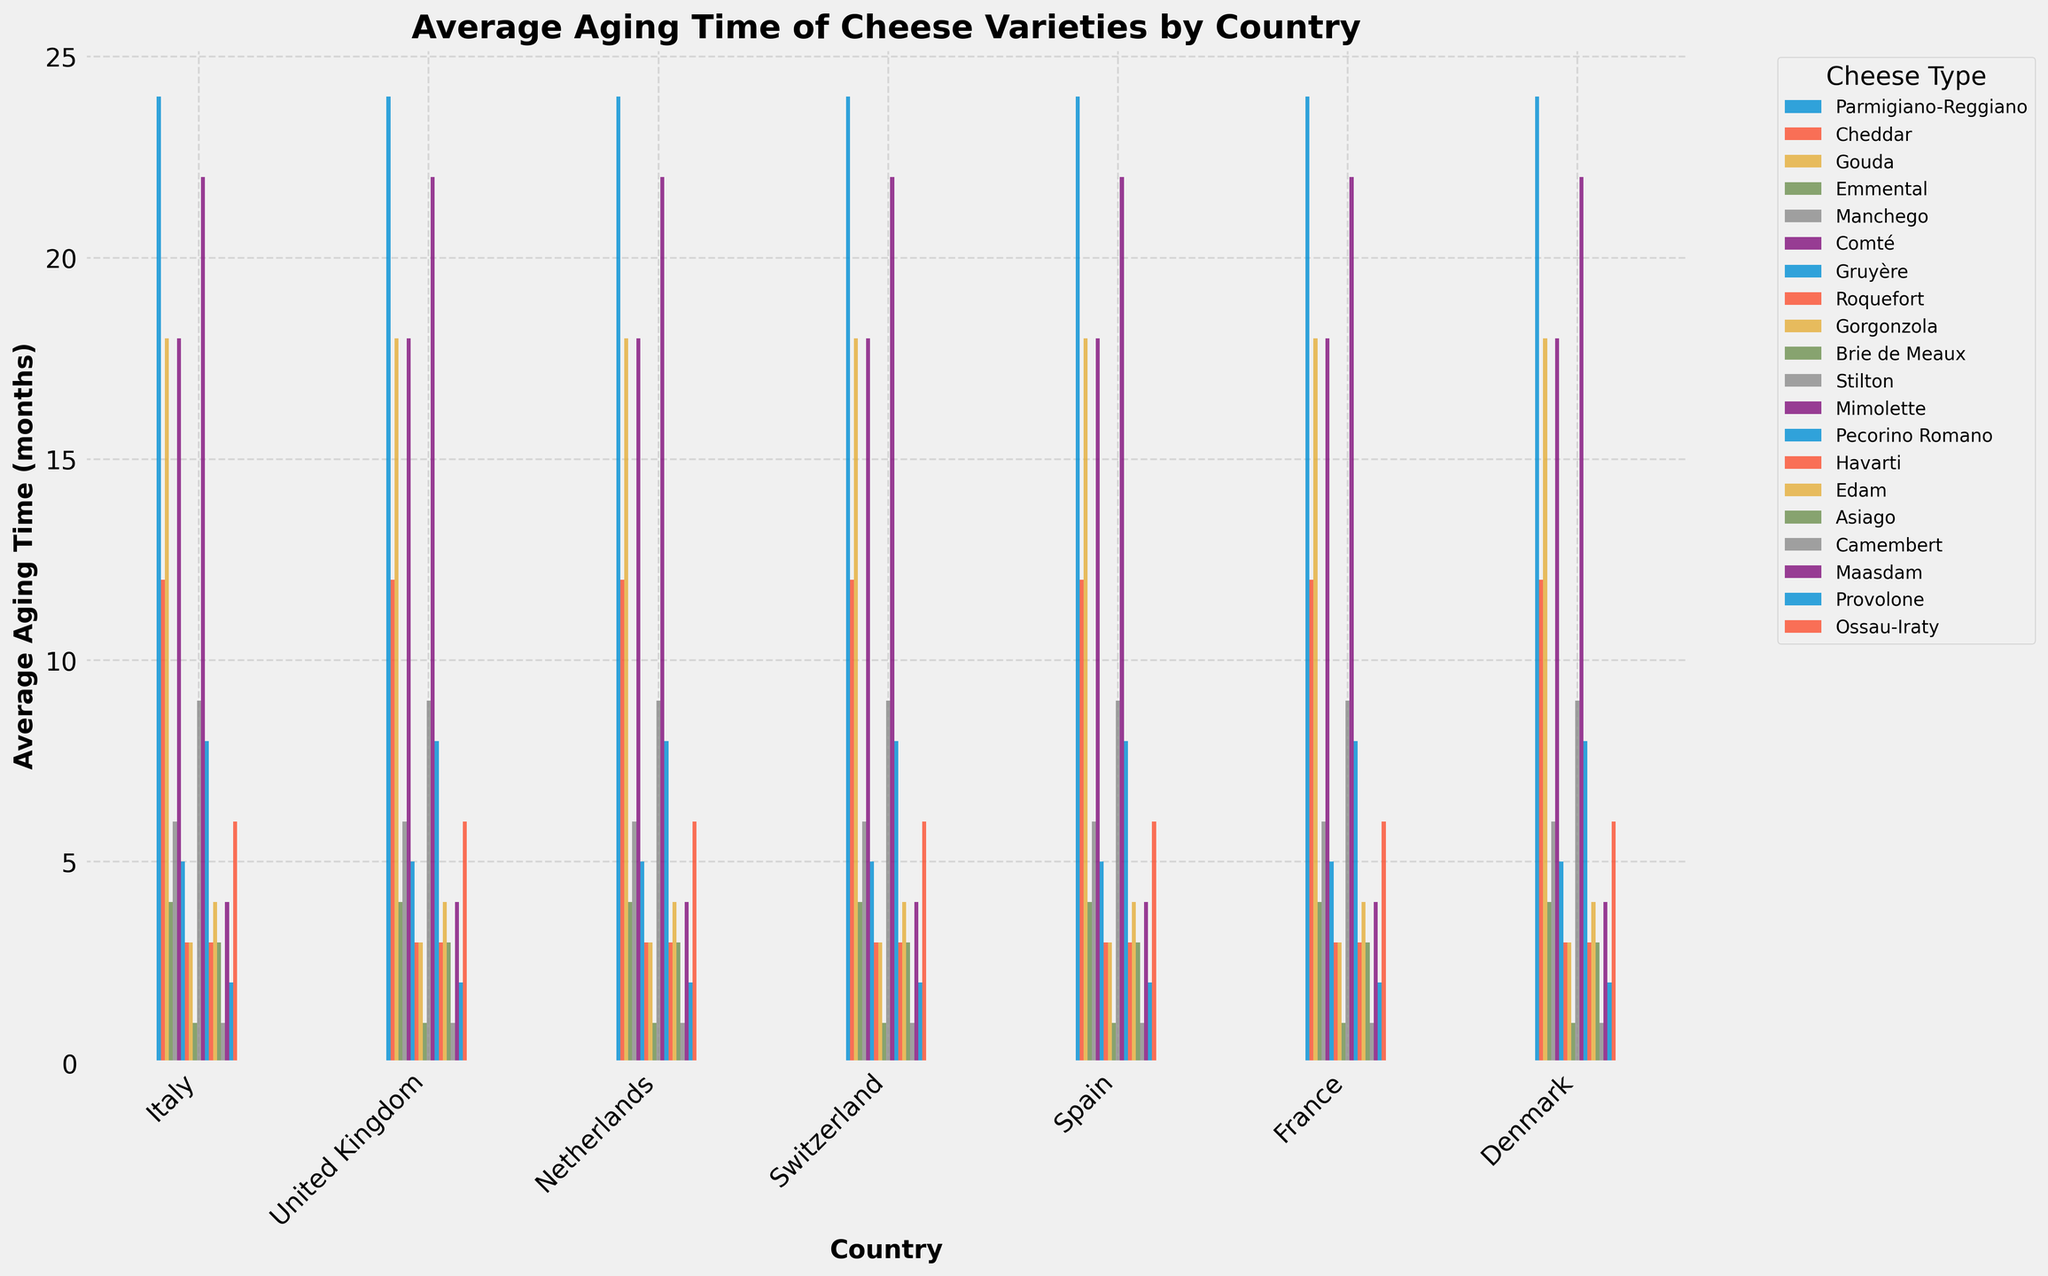Which country has the longest average aging time for cheese? The country with the longest average aging time for cheese can be identified by looking for the tallest bar in the plot.
Answer: Italy Which cheese variety aged in France has the shortest average aging time? To find the shortest aging time of a cheese from France, identify the shortest bar among the cheeses aged in France.
Answer: Camembert What is the difference in average aging time between Parmigiano-Reggiano from Italy and Brie de Meaux from France? Locate the bars for Parmigiano-Reggiano and Brie de Meaux, then subtract the aging time of Brie de Meaux from Parmigiano-Reggiano. The difference is 24 - 1 = 23 months.
Answer: 23 months How much longer is the average aging time of Gouda in the Netherlands compared to Havarti in Denmark? Find the bars for Gouda and Havarti, then subtract the aging time of Havarti from Gouda. The difference is 18 - 3 = 15 months.
Answer: 15 months Which cheese type has an equal average aging time in two different countries, and what is that aging time? Look for cheese types that have two bars with the same height.
Answer: Gouda has an equal average aging time in the Netherlands and France, both 18 months What is the combined average aging time for the Swiss cheeses shown in the plot? Sum the aging times of Emmental and Gruyère. The combined aging time is 4 + 5 = 9 months.
Answer: 9 months Are there any cheeses that have an average aging time of 1 month? If so, name them and their country. Identify bars that represent 1 month of aging time and note their cheese types and countries.
Answer: Camembert from France and Brie de Meaux from France Which country has the most variety of cheeses represented in the plot? Count the number of different cheese bars for each country and determine which has the most.
Answer: France What is the median average aging time for the cheese varieties aged in Italy? Arrange the aging times for Italian cheeses in ascending order and find the median value: (2, 3, 3, 8, 24), the median is 3 months.
Answer: 3 months 